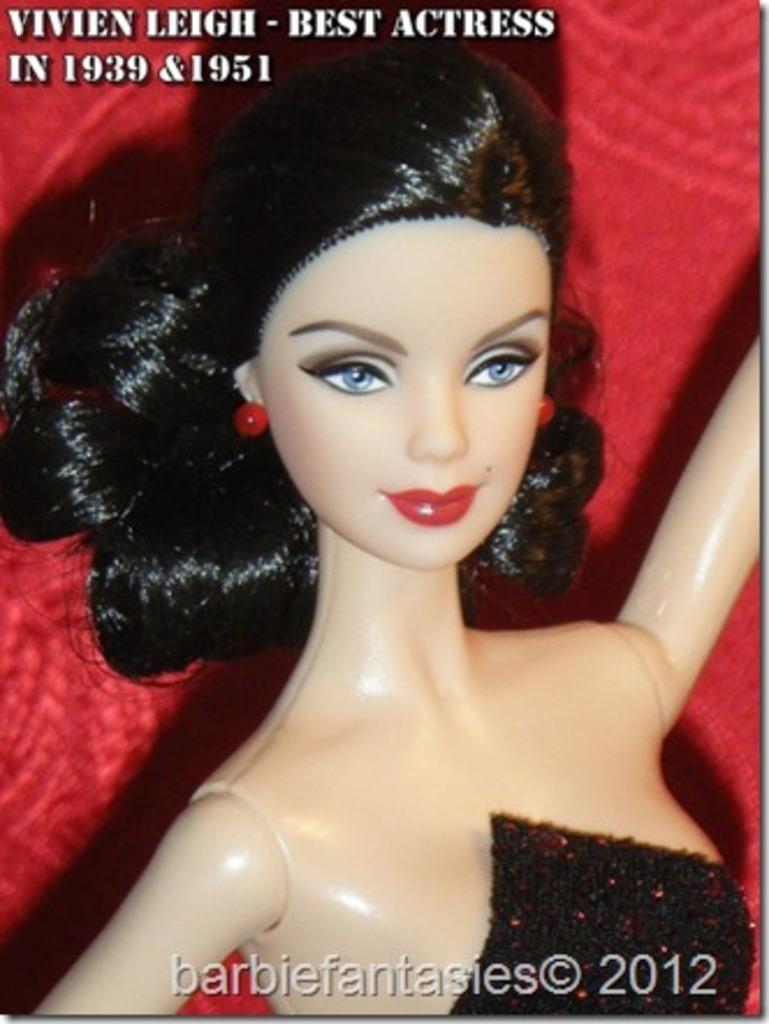Describe this image in one or two sentences. Here there is a woman, this is red color background. 